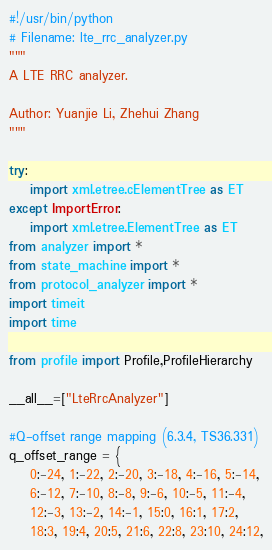Convert code to text. <code><loc_0><loc_0><loc_500><loc_500><_Python_>#!/usr/bin/python
# Filename: lte_rrc_analyzer.py
"""
A LTE RRC analyzer.

Author: Yuanjie Li, Zhehui Zhang
"""

try:
    import xml.etree.cElementTree as ET
except ImportError:
    import xml.etree.ElementTree as ET
from analyzer import *
from state_machine import *
from protocol_analyzer import *
import timeit
import time

from profile import Profile,ProfileHierarchy

__all__=["LteRrcAnalyzer"]

#Q-offset range mapping (6.3.4, TS36.331)
q_offset_range = {
    0:-24, 1:-22, 2:-20, 3:-18, 4:-16, 5:-14,
    6:-12, 7:-10, 8:-8, 9:-6, 10:-5, 11:-4,
    12:-3, 13:-2, 14:-1, 15:0, 16:1, 17:2,
    18:3, 19:4, 20:5, 21:6, 22:8, 23:10, 24:12,</code> 